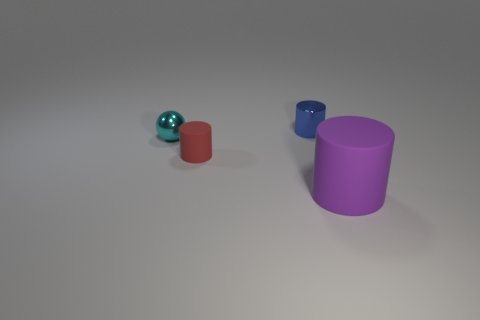Add 2 red cylinders. How many objects exist? 6 Subtract all balls. How many objects are left? 3 Add 2 tiny red objects. How many tiny red objects are left? 3 Add 3 gray shiny things. How many gray shiny things exist? 3 Subtract 0 blue blocks. How many objects are left? 4 Subtract all green metallic spheres. Subtract all red rubber cylinders. How many objects are left? 3 